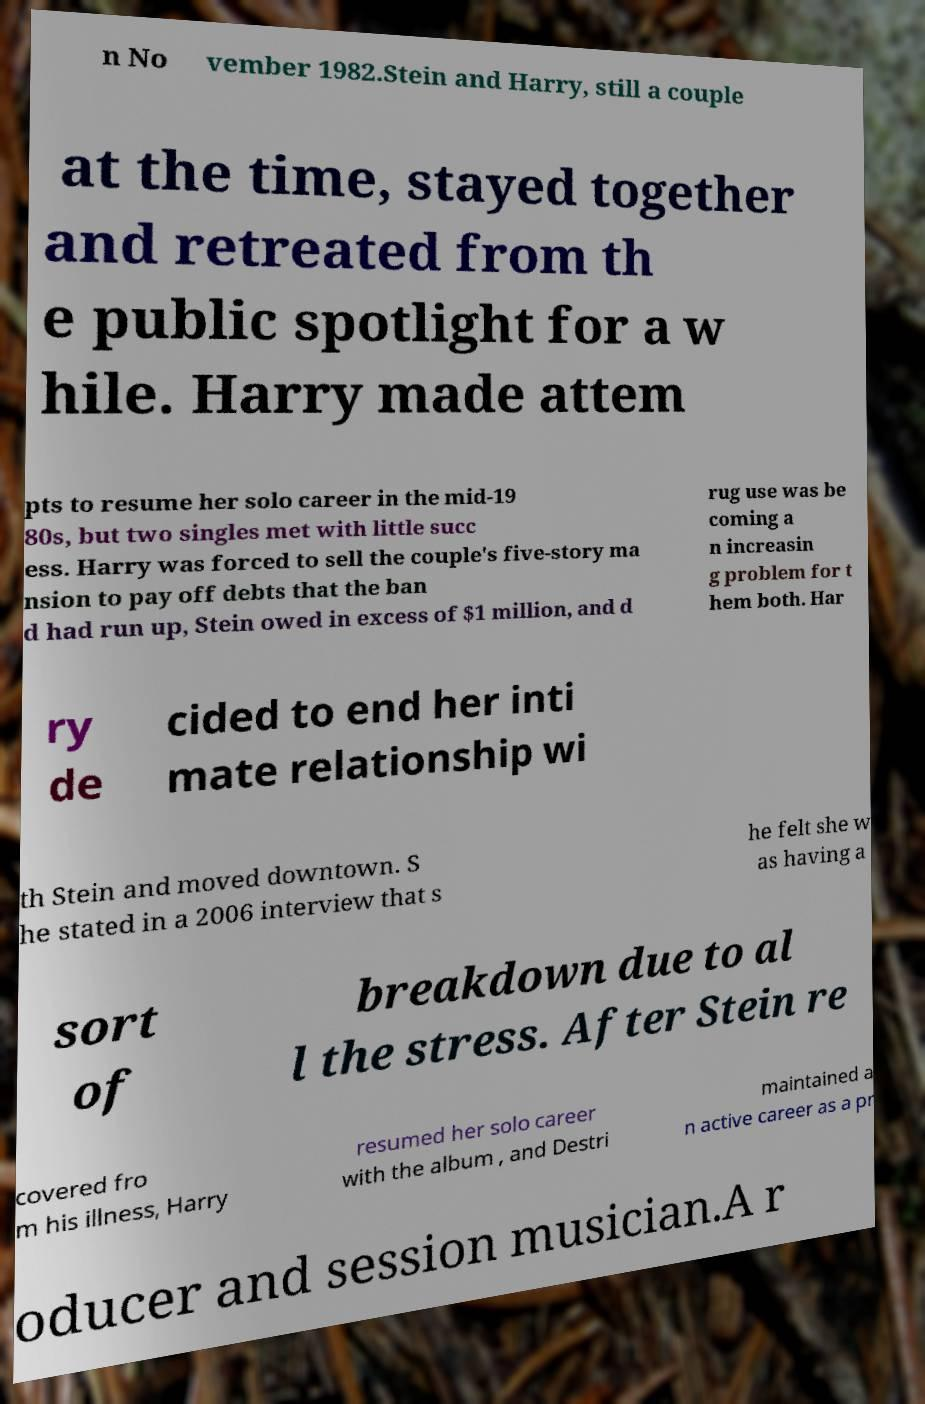Could you extract and type out the text from this image? n No vember 1982.Stein and Harry, still a couple at the time, stayed together and retreated from th e public spotlight for a w hile. Harry made attem pts to resume her solo career in the mid-19 80s, but two singles met with little succ ess. Harry was forced to sell the couple's five-story ma nsion to pay off debts that the ban d had run up, Stein owed in excess of $1 million, and d rug use was be coming a n increasin g problem for t hem both. Har ry de cided to end her inti mate relationship wi th Stein and moved downtown. S he stated in a 2006 interview that s he felt she w as having a sort of breakdown due to al l the stress. After Stein re covered fro m his illness, Harry resumed her solo career with the album , and Destri maintained a n active career as a pr oducer and session musician.A r 